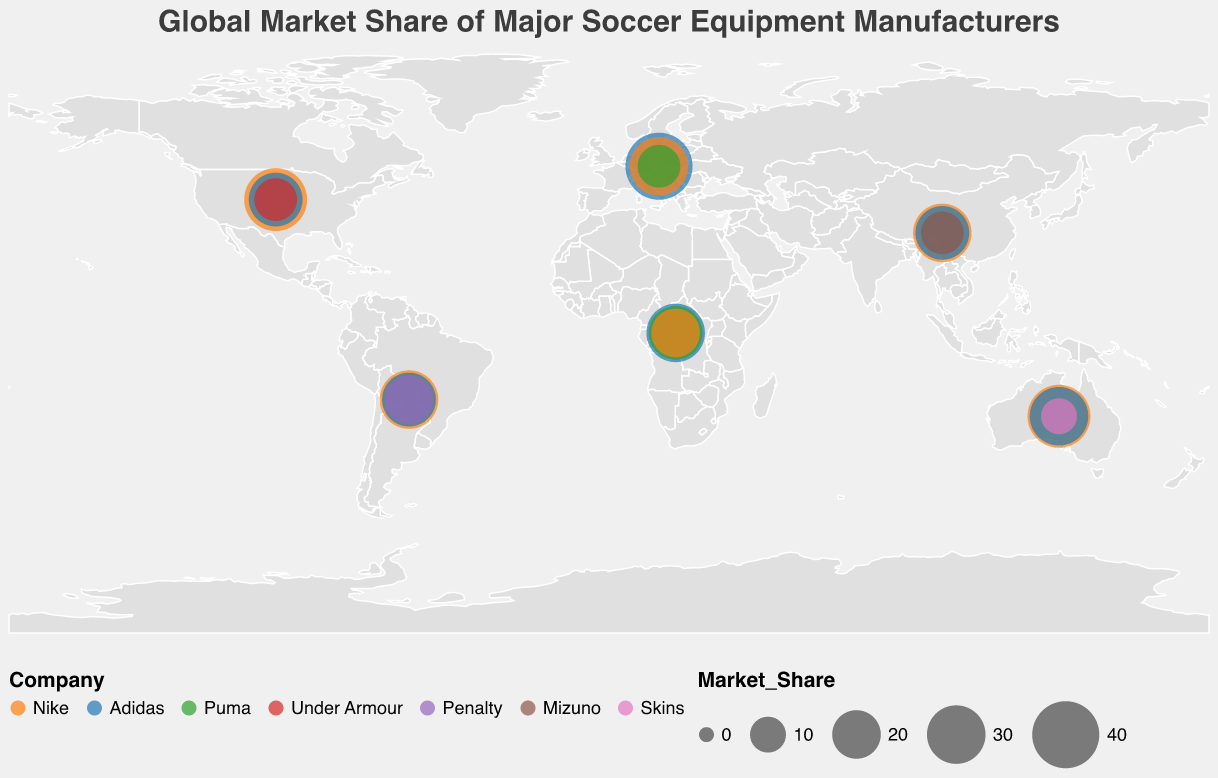Which company has the highest market share in Europe? The figure shows that Adidas has the highest market share in Europe with 40%.
Answer: Adidas What's the overall market share percentage of Nike in Asia and Africa combined? Nike's market share in Asia is 30%, and in Africa, it is 20%. So, combined, it is 30% + 20% = 50%.
Answer: 50% Compare the market shares of Nike and Adidas in North America. Which one is larger and by how much? In North America, Nike has a market share of 35% and Adidas has 25%. Nike's market share is larger by 35% - 25% = 10%.
Answer: Nike, larger by 10% Which region has the presence of the company Penalty? The figure indicates that Penalty is only present in South America.
Answer: South America What is the sum of market shares of all companies in Oceania? The market shares in Oceania for Nike, Adidas, and Skins are 35%, 30%, and 10%, respectively. The sum is 35% + 30% + 10% = 75%.
Answer: 75% Which company appears in all regions? The figure shows that Nike and Adidas both appear in all regions.
Answer: Nike and Adidas Which region does Mizuno have a market share, and what is it? Mizuno appears in Asia, with a market share of 15%.
Answer: Asia, 15% Which company has the lowest market share in Europe and what is it? Puma has the lowest market share in Europe with 15%.
Answer: Puma, 15% How does the market share of Adidas in South America compare to that in Oceania? Adidas has a 25% market share in South America and 30% in Oceania. The market share is 5% higher in Oceania.
Answer: Oceania, 5% higher 